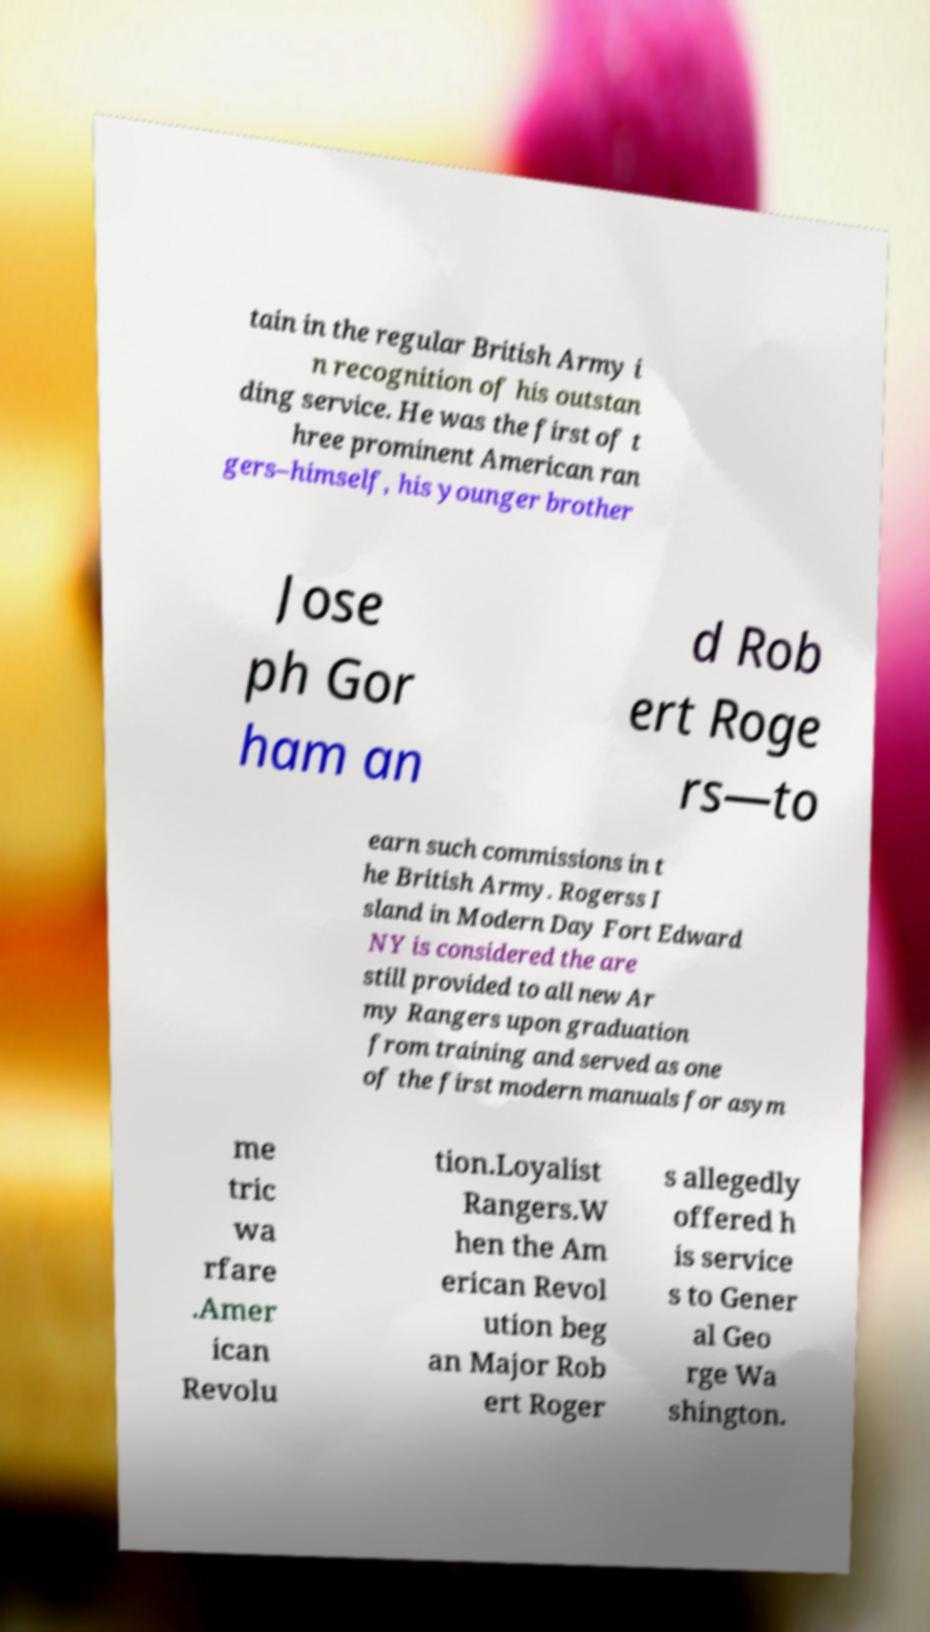There's text embedded in this image that I need extracted. Can you transcribe it verbatim? tain in the regular British Army i n recognition of his outstan ding service. He was the first of t hree prominent American ran gers–himself, his younger brother Jose ph Gor ham an d Rob ert Roge rs—to earn such commissions in t he British Army. Rogerss I sland in Modern Day Fort Edward NY is considered the are still provided to all new Ar my Rangers upon graduation from training and served as one of the first modern manuals for asym me tric wa rfare .Amer ican Revolu tion.Loyalist Rangers.W hen the Am erican Revol ution beg an Major Rob ert Roger s allegedly offered h is service s to Gener al Geo rge Wa shington. 